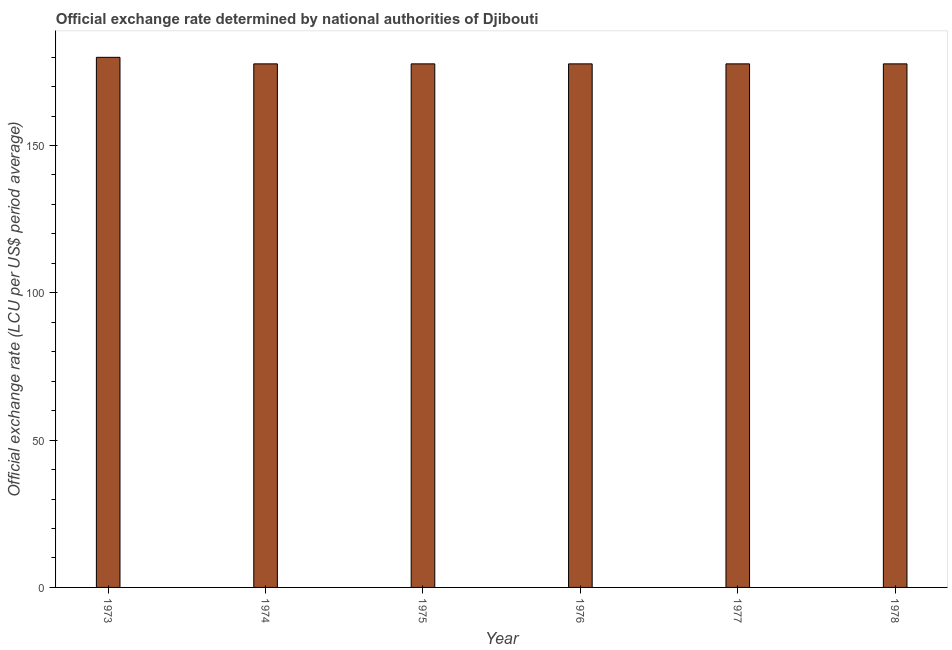What is the title of the graph?
Your response must be concise. Official exchange rate determined by national authorities of Djibouti. What is the label or title of the Y-axis?
Offer a terse response. Official exchange rate (LCU per US$ period average). What is the official exchange rate in 1977?
Offer a terse response. 177.72. Across all years, what is the maximum official exchange rate?
Ensure brevity in your answer.  179.94. Across all years, what is the minimum official exchange rate?
Your answer should be very brief. 177.72. In which year was the official exchange rate minimum?
Give a very brief answer. 1974. What is the sum of the official exchange rate?
Give a very brief answer. 1068.55. What is the average official exchange rate per year?
Provide a short and direct response. 178.09. What is the median official exchange rate?
Your answer should be compact. 177.72. Do a majority of the years between 1977 and 1975 (inclusive) have official exchange rate greater than 150 ?
Your answer should be compact. Yes. Is the official exchange rate in 1976 less than that in 1978?
Offer a very short reply. No. Is the difference between the official exchange rate in 1977 and 1978 greater than the difference between any two years?
Provide a short and direct response. No. What is the difference between the highest and the second highest official exchange rate?
Ensure brevity in your answer.  2.22. Is the sum of the official exchange rate in 1974 and 1977 greater than the maximum official exchange rate across all years?
Your response must be concise. Yes. What is the difference between the highest and the lowest official exchange rate?
Offer a terse response. 2.22. How many bars are there?
Your answer should be compact. 6. Are all the bars in the graph horizontal?
Ensure brevity in your answer.  No. How many years are there in the graph?
Provide a succinct answer. 6. What is the difference between two consecutive major ticks on the Y-axis?
Keep it short and to the point. 50. What is the Official exchange rate (LCU per US$ period average) in 1973?
Ensure brevity in your answer.  179.94. What is the Official exchange rate (LCU per US$ period average) in 1974?
Offer a terse response. 177.72. What is the Official exchange rate (LCU per US$ period average) of 1975?
Keep it short and to the point. 177.72. What is the Official exchange rate (LCU per US$ period average) of 1976?
Your response must be concise. 177.72. What is the Official exchange rate (LCU per US$ period average) of 1977?
Offer a very short reply. 177.72. What is the Official exchange rate (LCU per US$ period average) of 1978?
Ensure brevity in your answer.  177.72. What is the difference between the Official exchange rate (LCU per US$ period average) in 1973 and 1974?
Keep it short and to the point. 2.22. What is the difference between the Official exchange rate (LCU per US$ period average) in 1973 and 1975?
Your answer should be very brief. 2.22. What is the difference between the Official exchange rate (LCU per US$ period average) in 1973 and 1976?
Provide a succinct answer. 2.22. What is the difference between the Official exchange rate (LCU per US$ period average) in 1973 and 1977?
Your answer should be very brief. 2.22. What is the difference between the Official exchange rate (LCU per US$ period average) in 1973 and 1978?
Give a very brief answer. 2.22. What is the difference between the Official exchange rate (LCU per US$ period average) in 1974 and 1976?
Your answer should be very brief. 0. What is the difference between the Official exchange rate (LCU per US$ period average) in 1975 and 1976?
Offer a terse response. 0. What is the difference between the Official exchange rate (LCU per US$ period average) in 1975 and 1977?
Provide a succinct answer. 0. What is the difference between the Official exchange rate (LCU per US$ period average) in 1975 and 1978?
Your answer should be compact. 0. What is the difference between the Official exchange rate (LCU per US$ period average) in 1976 and 1977?
Your answer should be very brief. 0. What is the ratio of the Official exchange rate (LCU per US$ period average) in 1973 to that in 1977?
Provide a succinct answer. 1.01. What is the ratio of the Official exchange rate (LCU per US$ period average) in 1975 to that in 1977?
Offer a terse response. 1. What is the ratio of the Official exchange rate (LCU per US$ period average) in 1975 to that in 1978?
Offer a very short reply. 1. 